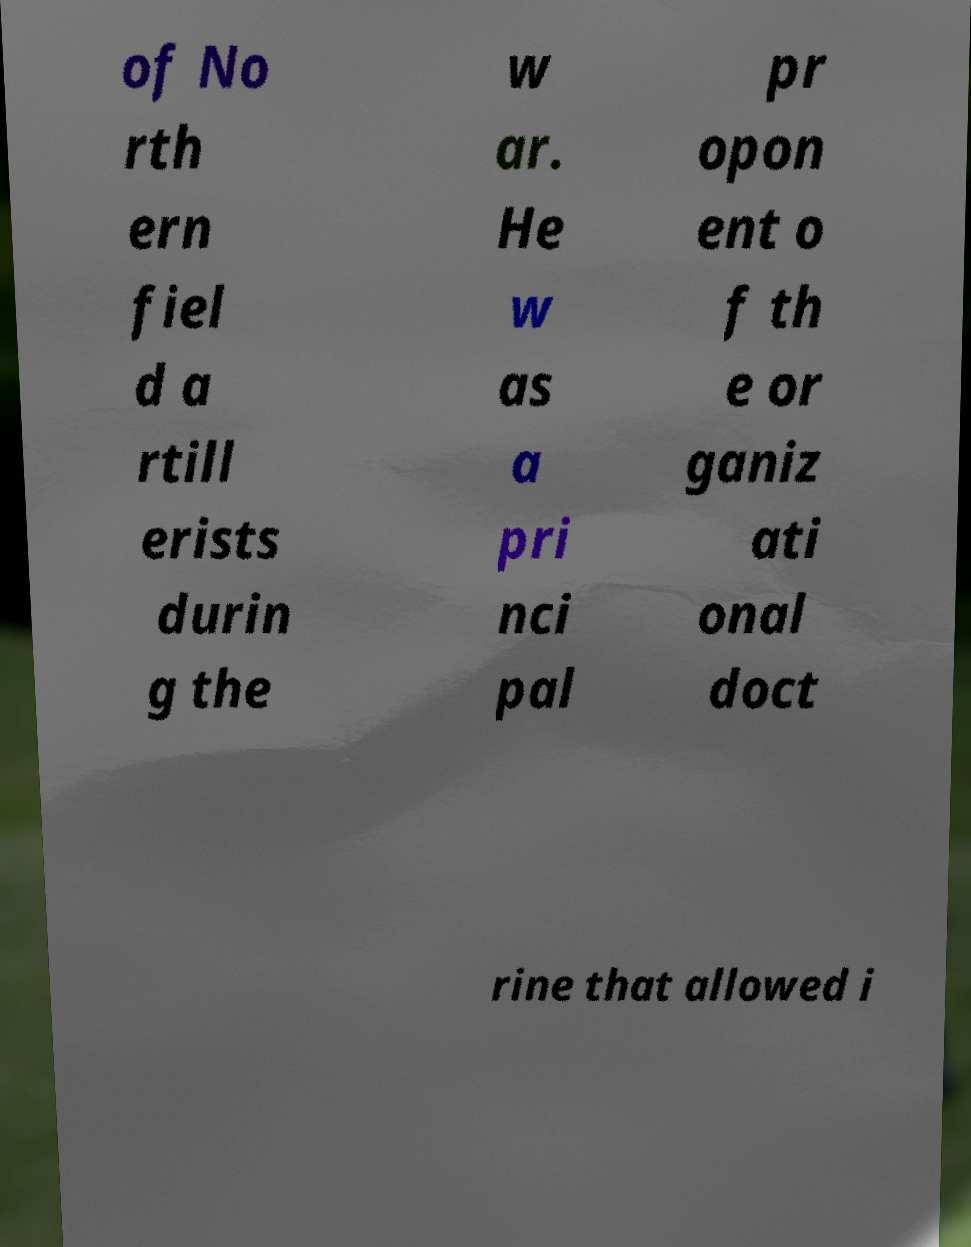I need the written content from this picture converted into text. Can you do that? of No rth ern fiel d a rtill erists durin g the w ar. He w as a pri nci pal pr opon ent o f th e or ganiz ati onal doct rine that allowed i 